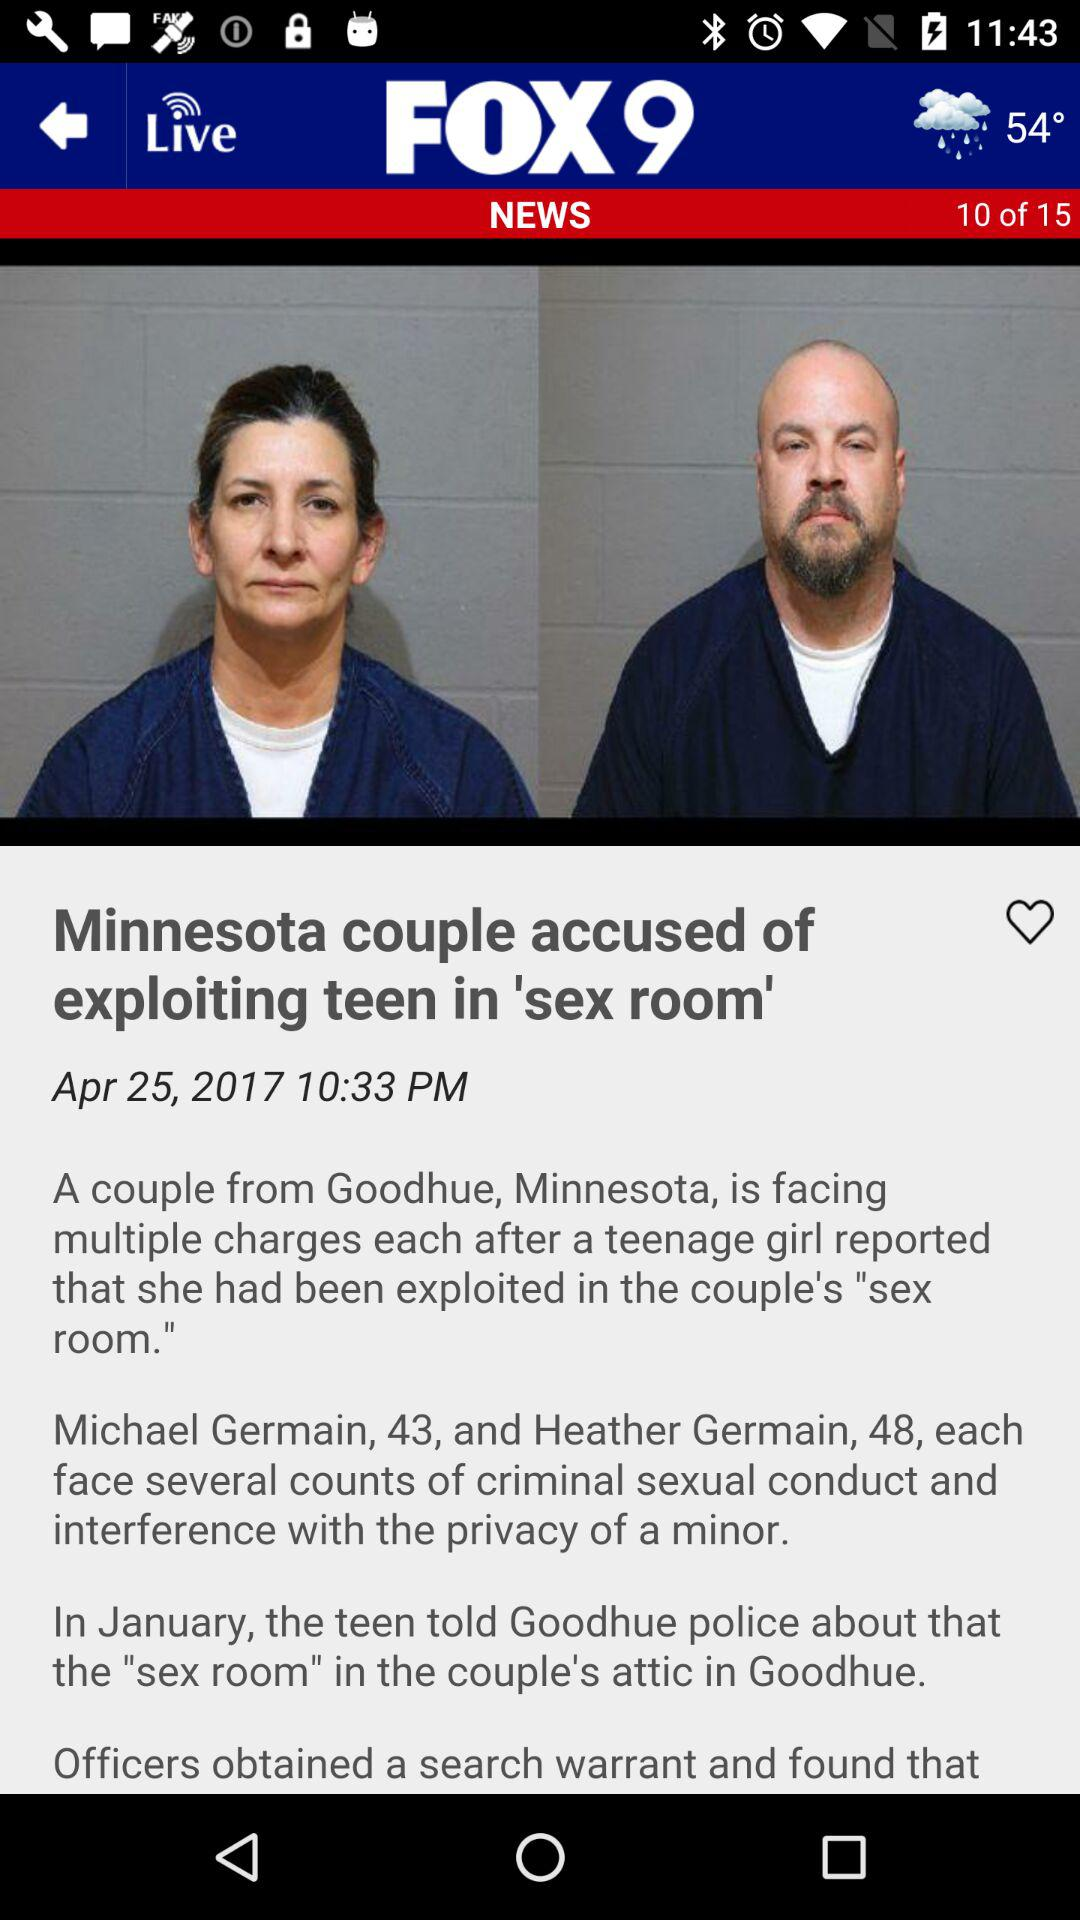Can you tell me more about the location mentioned in the news article? The article mentions Goodhue, a location in Minnesota where the reported incidents took place, including the setting up of a 'sex room' allegedly used for criminal activities. Is there any information on how the authorities responded? Yes, the authorities responded by obtaining a search warrant and conducting a thorough investigation, which confirmed the presence of the 'sex room' as described by the teenager in the attic of the couple's house. 